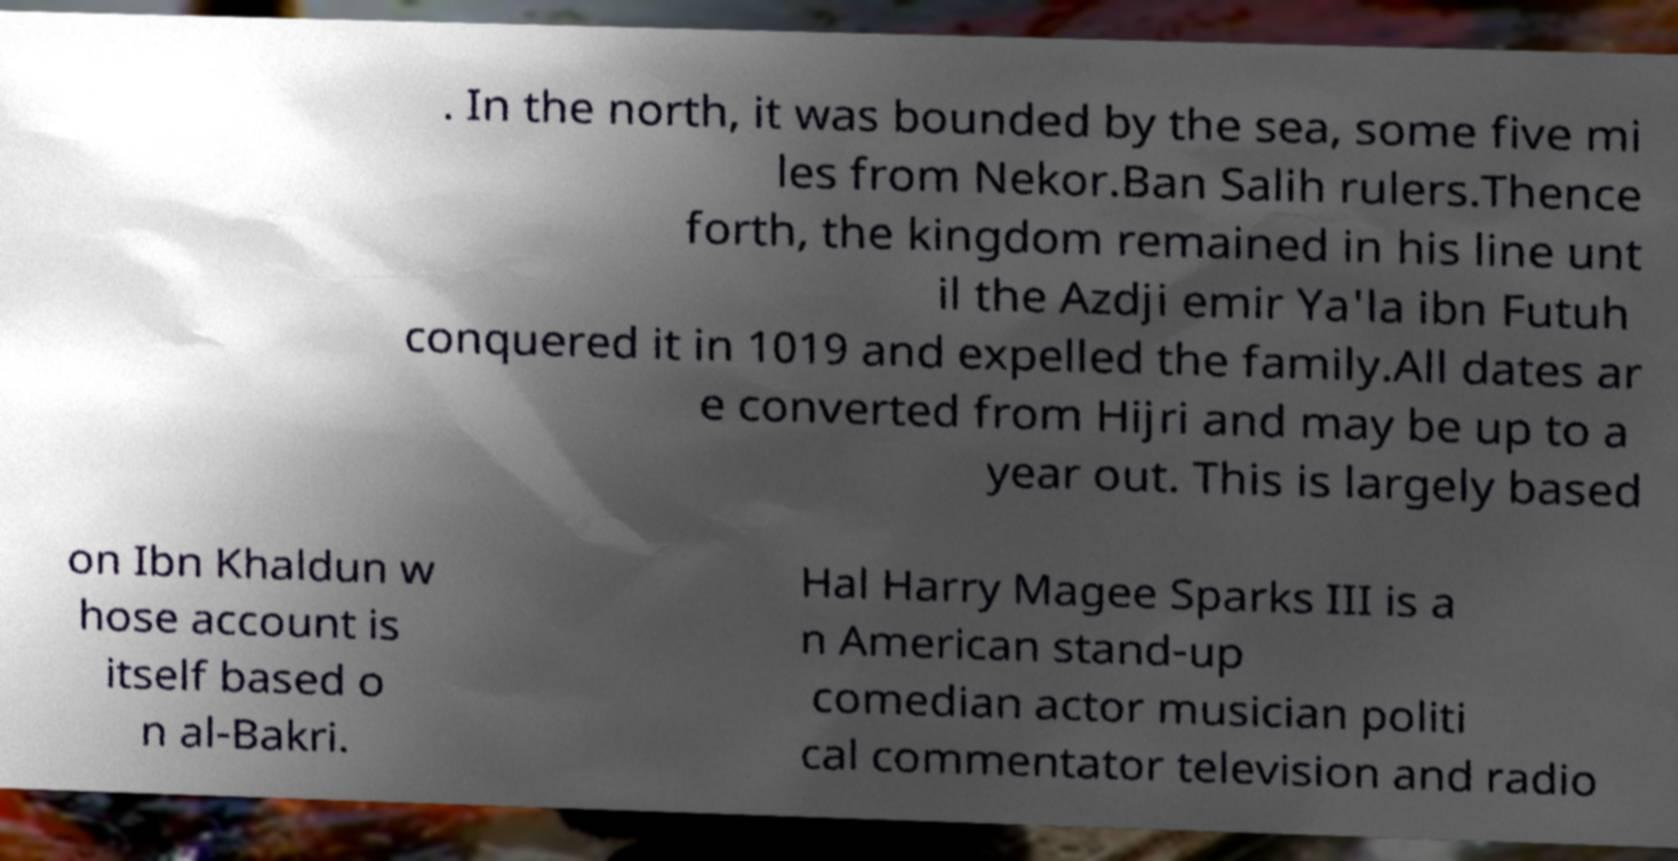Please read and relay the text visible in this image. What does it say? . In the north, it was bounded by the sea, some five mi les from Nekor.Ban Salih rulers.Thence forth, the kingdom remained in his line unt il the Azdji emir Ya'la ibn Futuh conquered it in 1019 and expelled the family.All dates ar e converted from Hijri and may be up to a year out. This is largely based on Ibn Khaldun w hose account is itself based o n al-Bakri. Hal Harry Magee Sparks III is a n American stand-up comedian actor musician politi cal commentator television and radio 